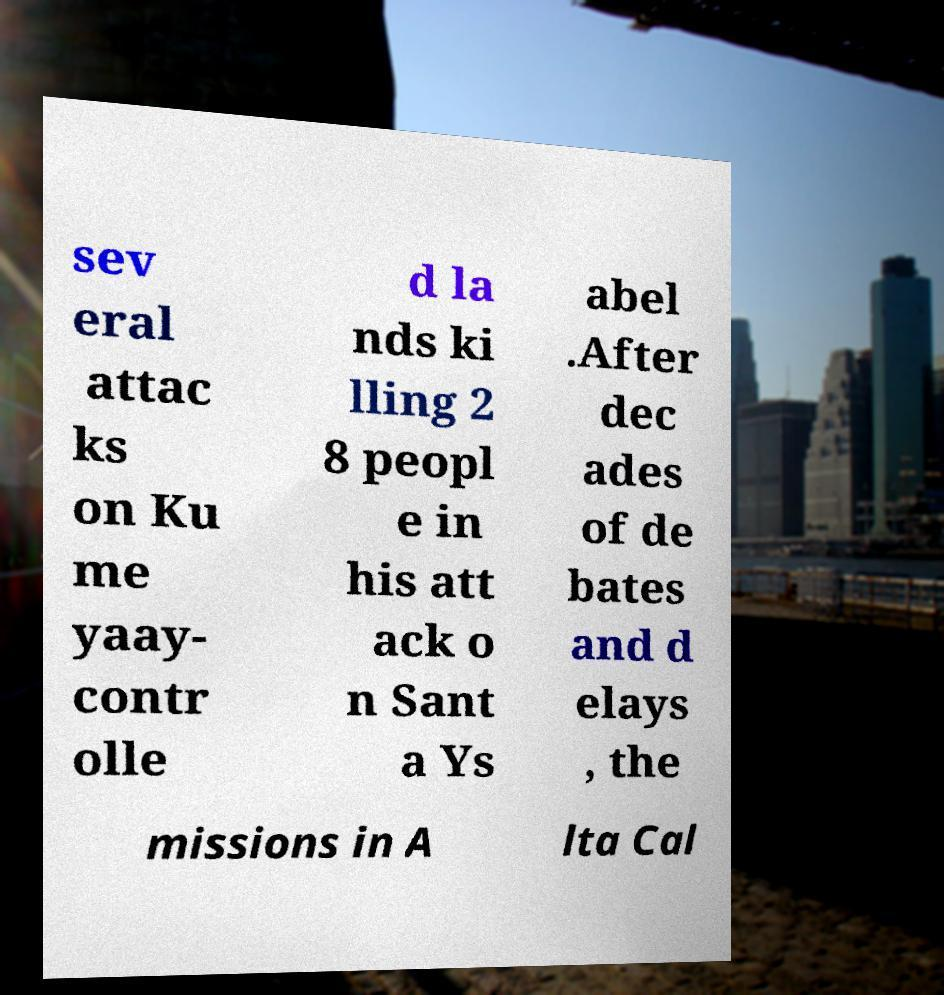Please identify and transcribe the text found in this image. sev eral attac ks on Ku me yaay- contr olle d la nds ki lling 2 8 peopl e in his att ack o n Sant a Ys abel .After dec ades of de bates and d elays , the missions in A lta Cal 